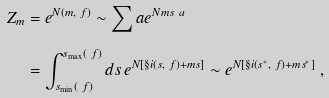<formula> <loc_0><loc_0><loc_500><loc_500>Z _ { m } & = e ^ { N ( m , \ f ) } \sim \sum _ { \ } a e ^ { N m s _ { \ } a } \\ & = \int _ { s _ { \min } ( \ f ) } ^ { s _ { \max } ( \ f ) } d s \, e ^ { N [ \S i ( s , \ f ) + m s ] } \sim e ^ { N [ \S i ( s ^ { * } , \ f ) + m s ^ { * } ] } \ ,</formula> 